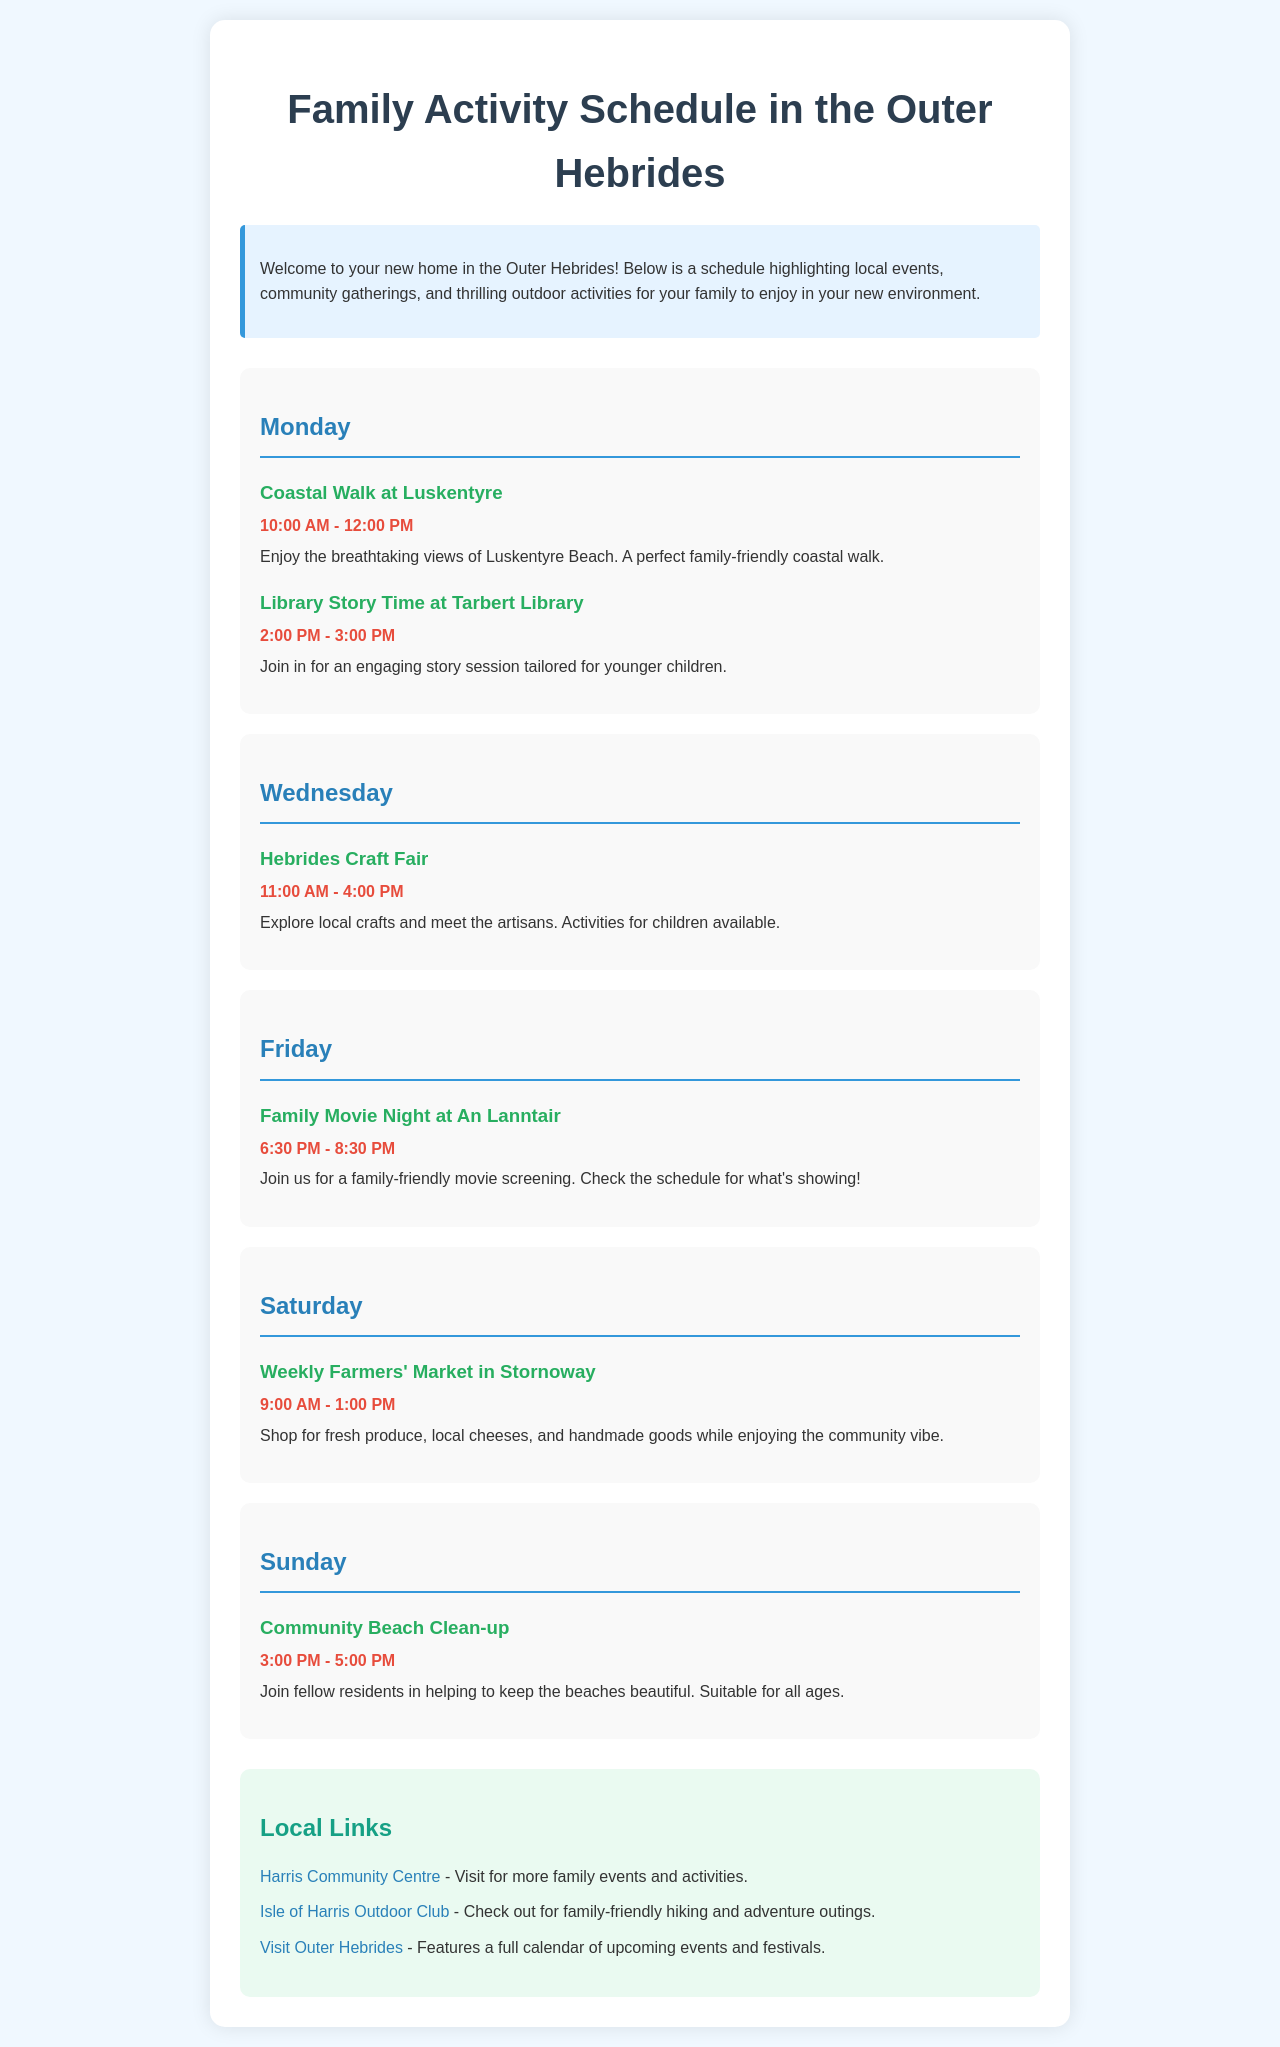What activity is scheduled for Monday at 10:00 AM? The activity scheduled for Monday at 10:00 AM is a Coastal Walk at Luskentyre.
Answer: Coastal Walk at Luskentyre What time does the Family Movie Night start on Friday? The Family Movie Night starts at 6:30 PM on Friday.
Answer: 6:30 PM How long does the Hebrides Craft Fair last on Wednesday? The Hebrides Craft Fair lasts from 11:00 AM to 4:00 PM, which is 5 hours.
Answer: 5 hours What is the activity planned for Sunday at 3:00 PM? The activity planned for Sunday at 3:00 PM is a Community Beach Clean-up.
Answer: Community Beach Clean-up What type of event is the weekly gathering in Stornoway on Saturday? The event in Stornoway on Saturday is a Farmers' Market.
Answer: Farmers' Market What is the purpose of the Community Beach Clean-up? The purpose of the Community Beach Clean-up is to help keep the beaches beautiful.
Answer: To help keep the beaches beautiful Which library will host the story time event on Monday? The story time event on Monday will be hosted at Tarbert Library.
Answer: Tarbert Library What age group is the Library Story Time designed for? The Library Story Time is tailored for younger children.
Answer: Younger children 